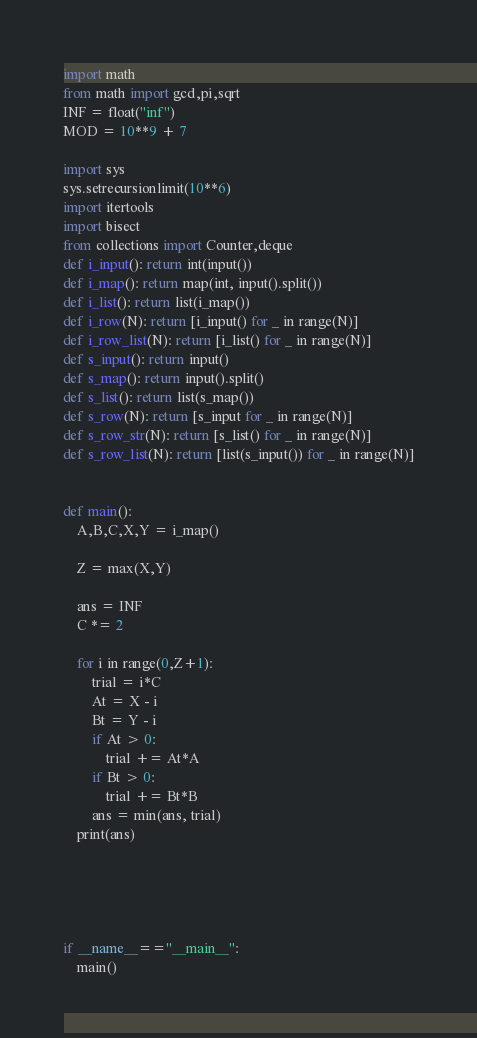Convert code to text. <code><loc_0><loc_0><loc_500><loc_500><_Python_>import math
from math import gcd,pi,sqrt
INF = float("inf")
MOD = 10**9 + 7

import sys
sys.setrecursionlimit(10**6)
import itertools
import bisect
from collections import Counter,deque
def i_input(): return int(input())
def i_map(): return map(int, input().split())
def i_list(): return list(i_map())
def i_row(N): return [i_input() for _ in range(N)]
def i_row_list(N): return [i_list() for _ in range(N)]
def s_input(): return input()
def s_map(): return input().split()
def s_list(): return list(s_map())
def s_row(N): return [s_input for _ in range(N)]
def s_row_str(N): return [s_list() for _ in range(N)]
def s_row_list(N): return [list(s_input()) for _ in range(N)]


def main():
    A,B,C,X,Y = i_map()

    Z = max(X,Y)

    ans = INF
    C *= 2

    for i in range(0,Z+1):
        trial = i*C
        At = X - i
        Bt = Y - i
        if At > 0:
            trial += At*A
        if Bt > 0:
            trial += Bt*B
        ans = min(ans, trial)
    print(ans)

  
  
 
  
if __name__=="__main__":
    main()
</code> 